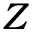Convert formula to latex. <formula><loc_0><loc_0><loc_500><loc_500>\boldsymbol Z</formula> 